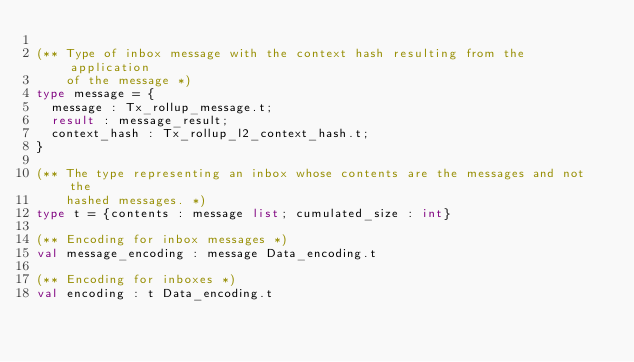Convert code to text. <code><loc_0><loc_0><loc_500><loc_500><_OCaml_>
(** Type of inbox message with the context hash resulting from the application
    of the message *)
type message = {
  message : Tx_rollup_message.t;
  result : message_result;
  context_hash : Tx_rollup_l2_context_hash.t;
}

(** The type representing an inbox whose contents are the messages and not the
    hashed messages. *)
type t = {contents : message list; cumulated_size : int}

(** Encoding for inbox messages *)
val message_encoding : message Data_encoding.t

(** Encoding for inboxes *)
val encoding : t Data_encoding.t
</code> 